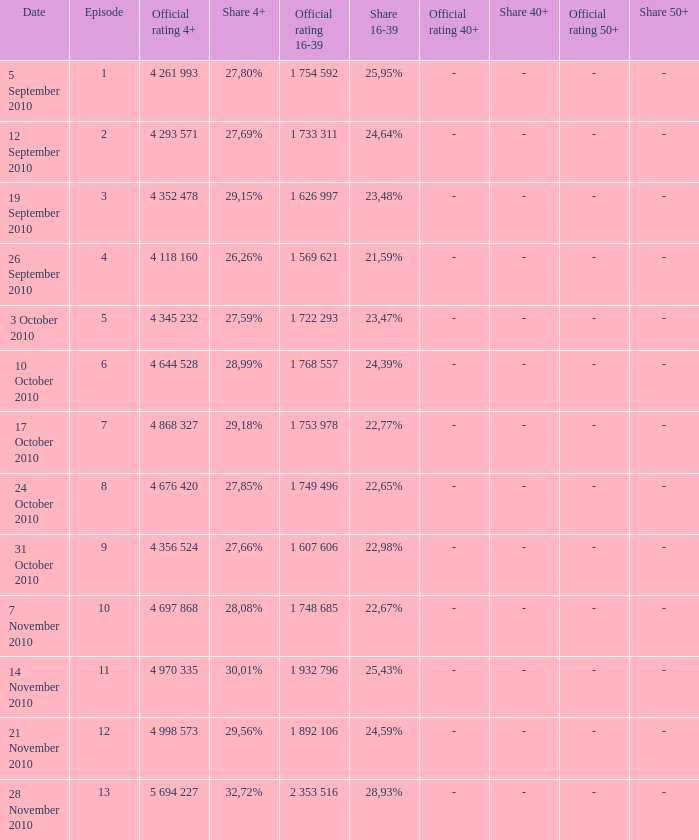What is the official 4+ rating of the episode with a 16-39 share of 24,59%? 4 998 573. 